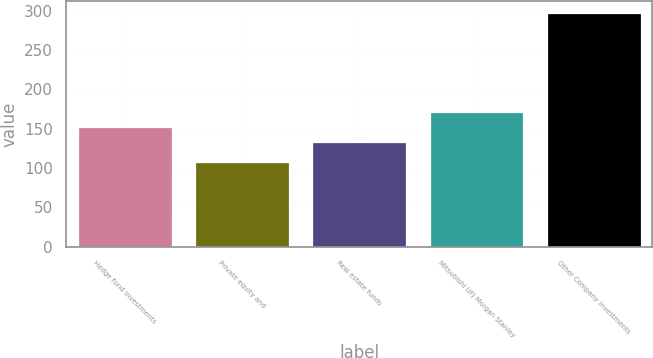<chart> <loc_0><loc_0><loc_500><loc_500><bar_chart><fcel>Hedge fund investments<fcel>Private equity and<fcel>Real estate funds<fcel>Mitsubishi UFJ Morgan Stanley<fcel>Other Company investments<nl><fcel>151.9<fcel>108<fcel>133<fcel>170.8<fcel>297<nl></chart> 